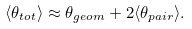Convert formula to latex. <formula><loc_0><loc_0><loc_500><loc_500>\langle \theta _ { t o t } \rangle \approx \theta _ { g e o m } + 2 \langle \theta _ { p a i r } \rangle .</formula> 